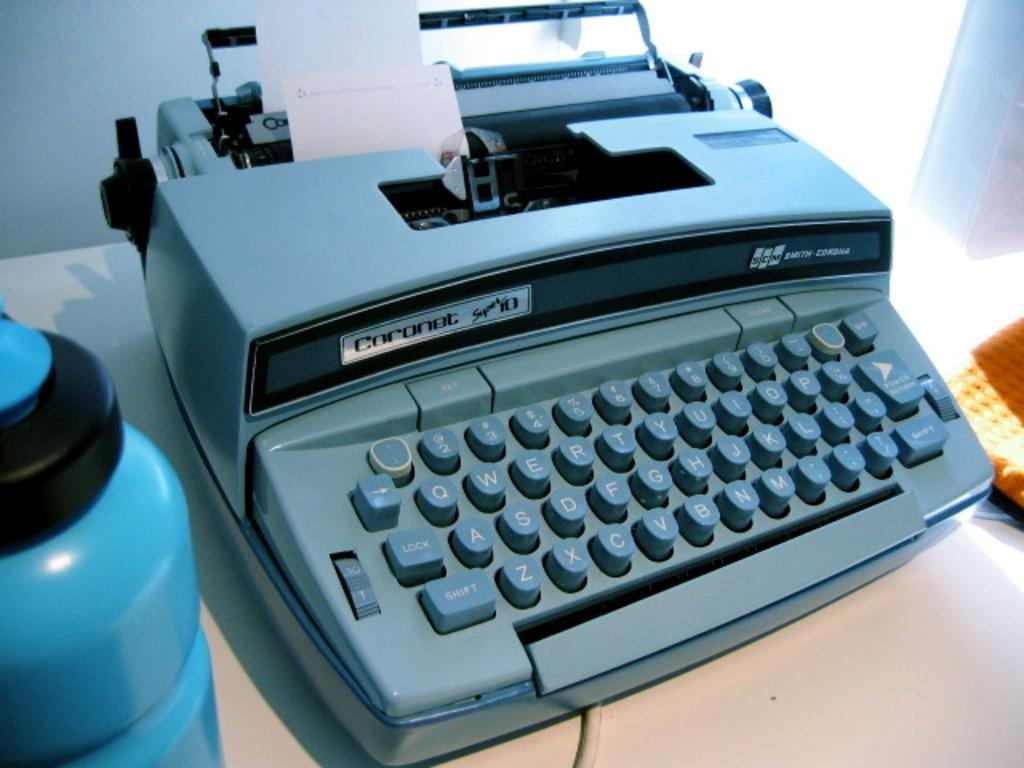<image>
Describe the image concisely. a typewriter that says Coronet on the top of ot 